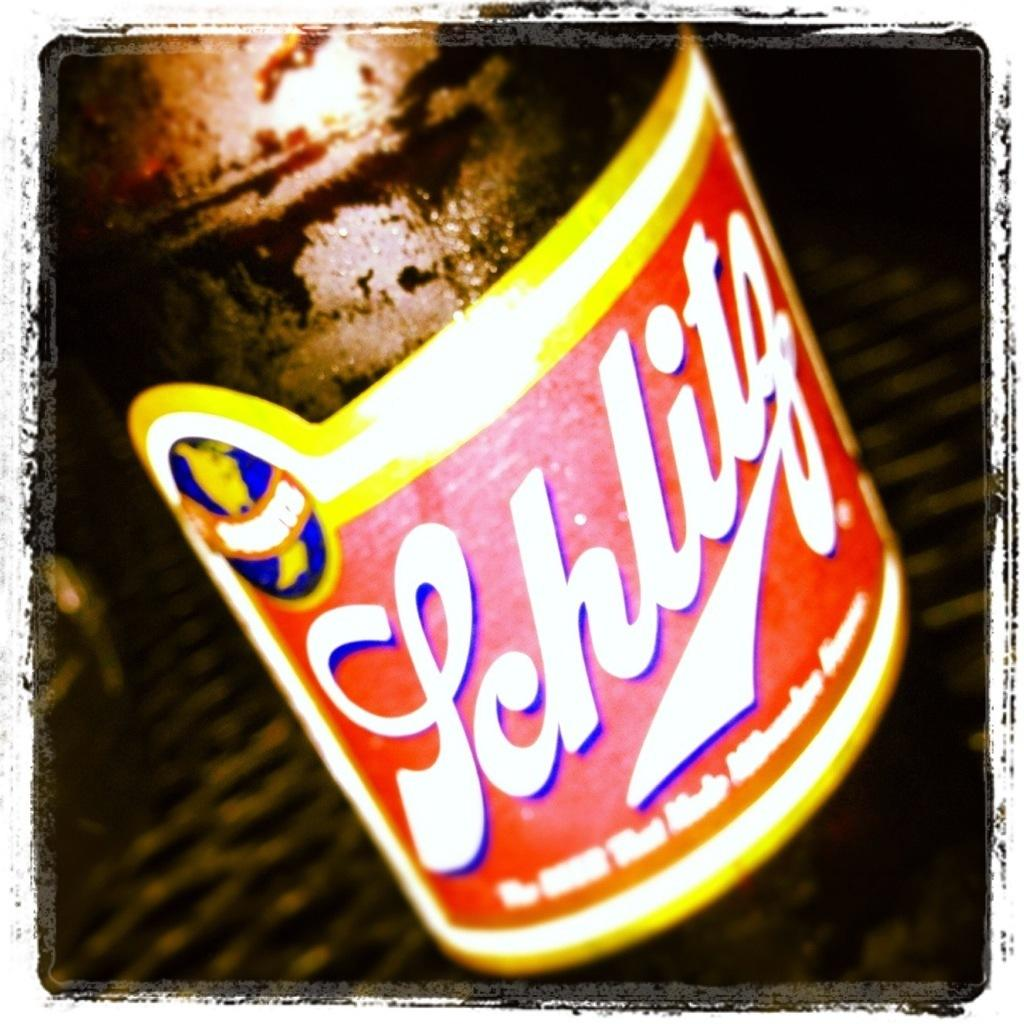What is on the bottle in the image? There is a colorful sticker on a bottle in the image. Can you describe the background of the image? The background of the image is blurred. What type of underwear is hanging from the sky in the image? There is no underwear or sky present in the image; it only features a bottle with a colorful sticker and a blurred background. 